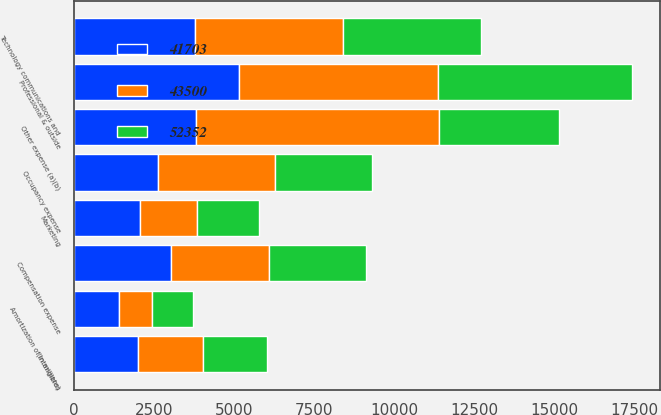Convert chart. <chart><loc_0><loc_0><loc_500><loc_500><stacked_bar_chart><ecel><fcel>(in millions)<fcel>Compensation expense<fcel>Occupancy expense<fcel>Technology communications and<fcel>Professional & outside<fcel>Marketing<fcel>Other expense (a)(b)<fcel>Amortization of intangibles<nl><fcel>43500<fcel>2009<fcel>3038<fcel>3666<fcel>4624<fcel>6232<fcel>1777<fcel>7594<fcel>1050<nl><fcel>52352<fcel>2008<fcel>3038<fcel>3038<fcel>4315<fcel>6053<fcel>1913<fcel>3740<fcel>1263<nl><fcel>41703<fcel>2007<fcel>3038<fcel>2608<fcel>3779<fcel>5140<fcel>2070<fcel>3814<fcel>1394<nl></chart> 